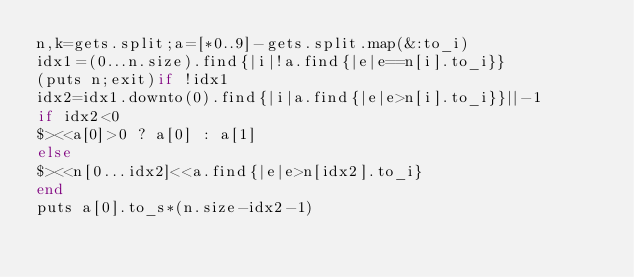<code> <loc_0><loc_0><loc_500><loc_500><_Ruby_>n,k=gets.split;a=[*0..9]-gets.split.map(&:to_i)
idx1=(0...n.size).find{|i|!a.find{|e|e==n[i].to_i}}
(puts n;exit)if !idx1
idx2=idx1.downto(0).find{|i|a.find{|e|e>n[i].to_i}}||-1
if idx2<0
$><<a[0]>0 ? a[0] : a[1]
else
$><<n[0...idx2]<<a.find{|e|e>n[idx2].to_i}
end
puts a[0].to_s*(n.size-idx2-1)</code> 